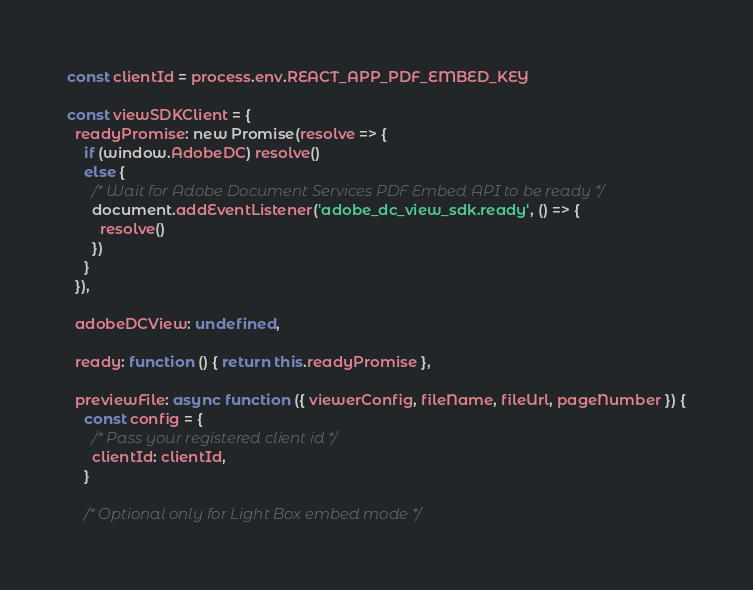<code> <loc_0><loc_0><loc_500><loc_500><_JavaScript_>const clientId = process.env.REACT_APP_PDF_EMBED_KEY

const viewSDKClient = {
  readyPromise: new Promise(resolve => {
    if (window.AdobeDC) resolve()
    else {
      /* Wait for Adobe Document Services PDF Embed API to be ready */
      document.addEventListener('adobe_dc_view_sdk.ready', () => {
        resolve()
      })
    }
  }),

  adobeDCView: undefined,

  ready: function () { return this.readyPromise },

  previewFile: async function ({ viewerConfig, fileName, fileUrl, pageNumber }) {
    const config = {
      /* Pass your registered client id */
      clientId: clientId,
    }

    /* Optional only for Light Box embed mode */</code> 